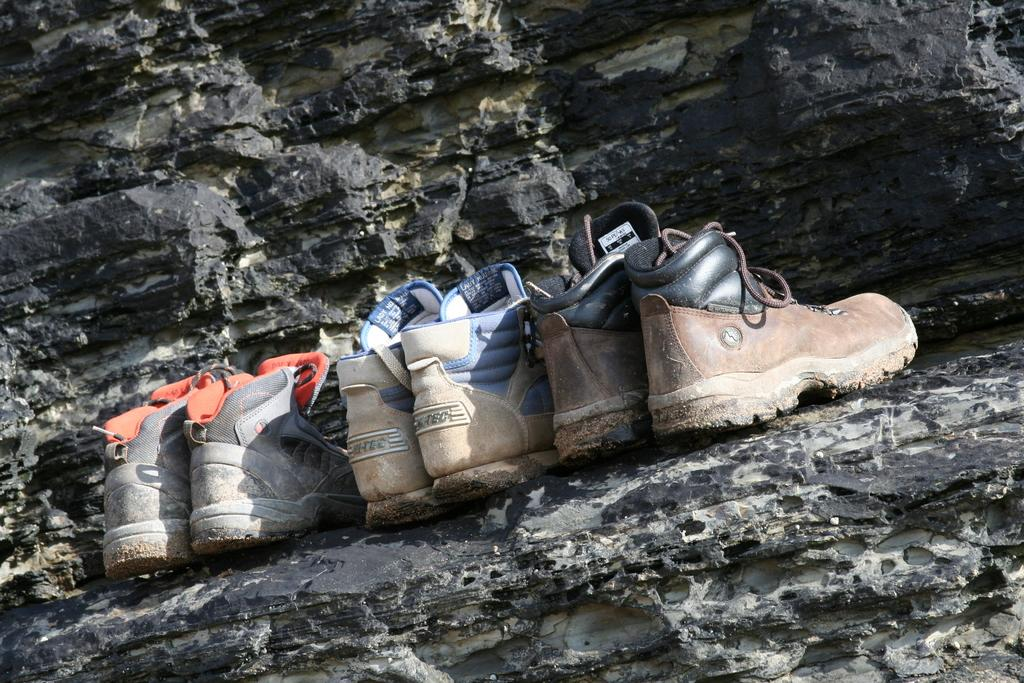How many pairs of shoes are in the image? There are three pairs of shoes in the image. Where are the shoes placed in the image? The shoes are on a rock. What colors can be seen among the shoes in the image? The shoes are in various colors, including black, brown, cream, blue, ash, and orange. How does the wealth of the person who owns these shoes affect the image? The image does not provide any information about the wealth of the person who owns the shoes, so it cannot be determined how it affects the image. 